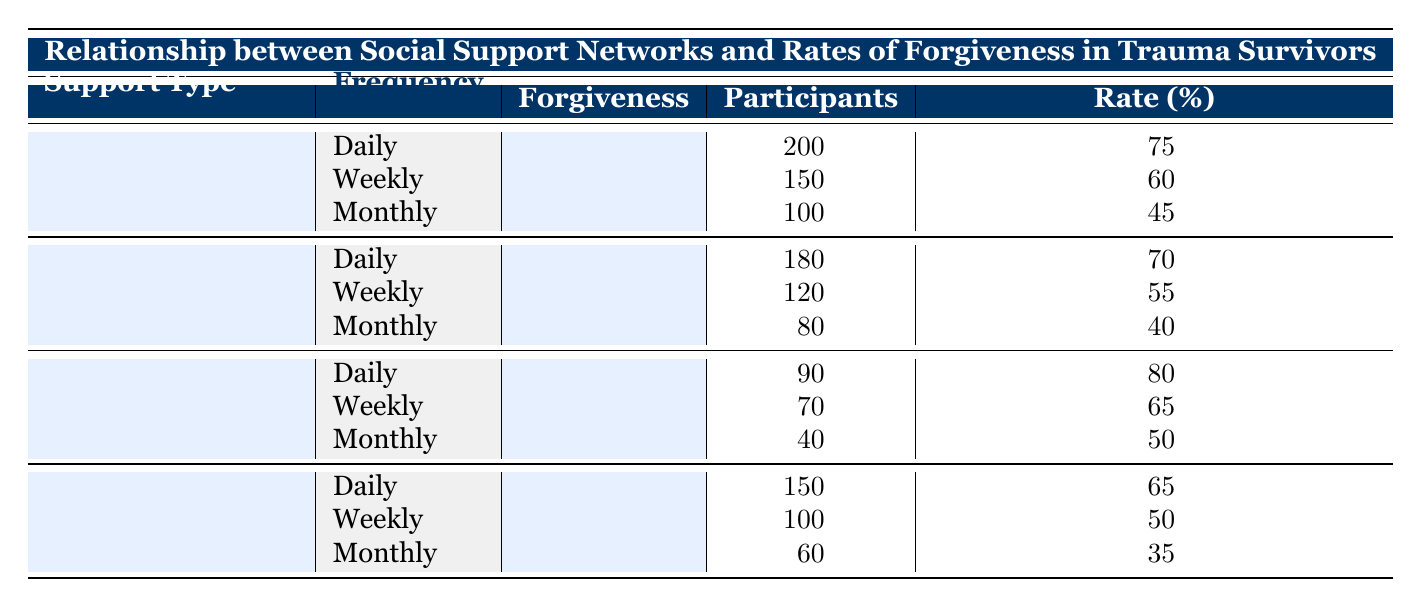What is the forgiveness rate for participants who have daily support from family? The table indicates that the forgiveness rate for participants who receive family support daily is 75%. This data is listed under the Family support type and Daily frequency row.
Answer: 75% How many participants are there in total who receive support from friends on a weekly basis? The table shows that there are 120 participants who receive friend support weekly. This information can be found in the Friends support type, under the Weekly frequency row.
Answer: 120 Is the forgiveness rate for support groups higher or lower than that for online communities on a daily basis? The forgiveness rate for support groups daily is 80%, while the forgiveness rate for online communities is 65%. Since 80% is greater than 65%, the answer is higher.
Answer: Higher What is the average forgiveness rate across all support types for monthly support? To find the average, sum the monthly forgiveness rates: (45 + 40 + 50 + 35) = 170, then divide by 4 (the number of support types), yielding an average of 42.5%.
Answer: 42.5% Does the data suggest that participants who receive daily support from any category generally have higher forgiveness rates than those who receive monthly support? By examining the daily forgiveness rates (75, 70, 80, 65) and monthly rates (45, 40, 50, 35), we find that daily rates are consistently higher than monthly rates across all support types. Thus, the data does support this claim.
Answer: Yes What is the difference in the number of participants between those who have family support versus those who have support groups on a monthly basis? For family support, there are 100 participants with monthly support, and for support groups, there are 40 participants. The difference in the number of participants is calculated as: 100 - 40 = 60.
Answer: 60 How many total participants are there across all support types who have daily support? The totals for daily support from each type are: Family (200) + Friends (180) + Support Groups (90) + Online Communities (150) = 620 participants in total.
Answer: 620 What percentage of participants in support groups receive daily support? Since there are 90 participants in support groups and they all receive daily support, the percentage is calculated as: (90 participants out of total participants in the group). However, since this only involves the support type, the answer stays as is, referring specifically to those who receive support daily, which is always 100% of those counted in this category.
Answer: 100% Which type of social support leads to the highest forgiveness rate? From the table, the highest forgiveness rate is found in Support Groups with a rate of 80% for daily support. Therefore, Support Groups lead to the highest forgiveness rate compared to other support types.
Answer: Support Groups 